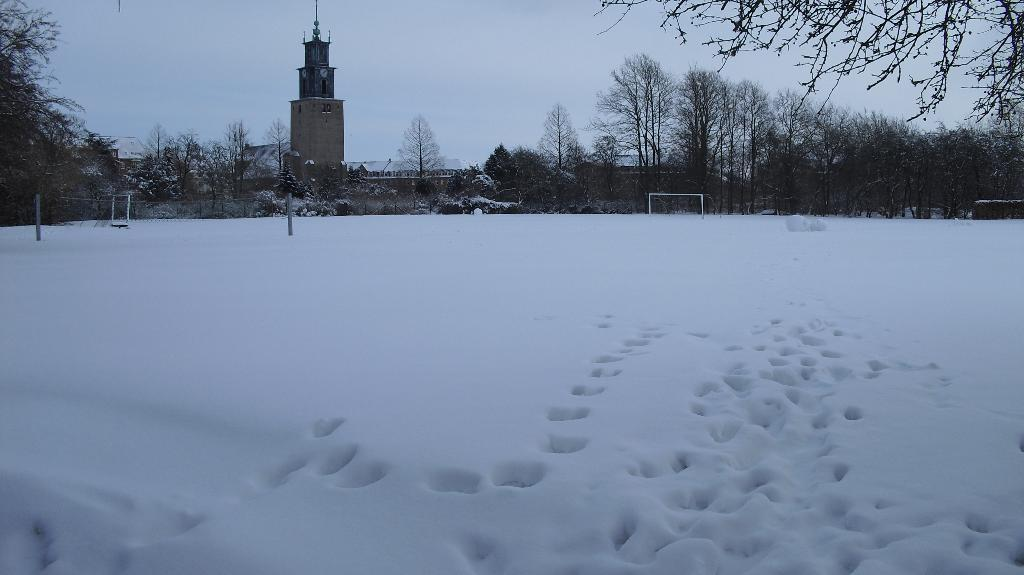What is the primary color of the snow in the image? The snow in the image is depicted in white color. What can be seen in the background of the image? There are trees and a clock tower visible in the background of the image. What is the color of the sky in the image? The sky is white in color. Can you touch the mark on the dust in the image? There is no mark or dust present in the image; it features snow, trees, a clock tower, and a white sky. 